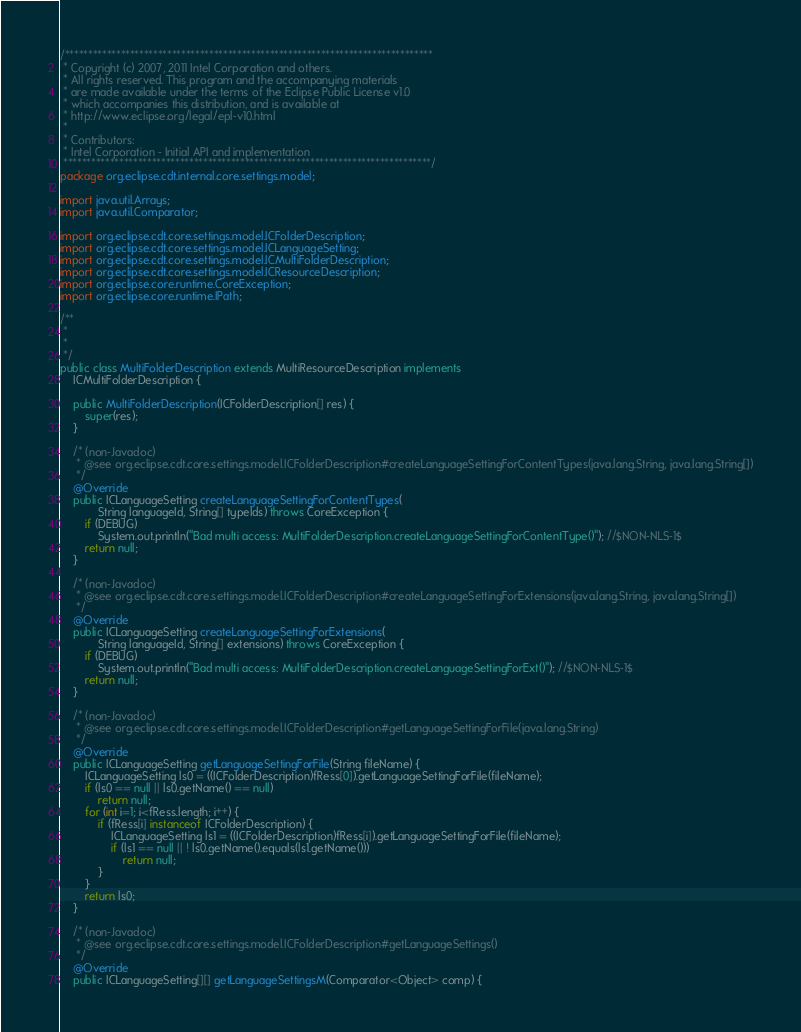<code> <loc_0><loc_0><loc_500><loc_500><_Java_>/*******************************************************************************
 * Copyright (c) 2007, 2011 Intel Corporation and others.
 * All rights reserved. This program and the accompanying materials
 * are made available under the terms of the Eclipse Public License v1.0
 * which accompanies this distribution, and is available at
 * http://www.eclipse.org/legal/epl-v10.html
 *
 * Contributors:
 * Intel Corporation - Initial API and implementation
 *******************************************************************************/
package org.eclipse.cdt.internal.core.settings.model;

import java.util.Arrays;
import java.util.Comparator;

import org.eclipse.cdt.core.settings.model.ICFolderDescription;
import org.eclipse.cdt.core.settings.model.ICLanguageSetting;
import org.eclipse.cdt.core.settings.model.ICMultiFolderDescription;
import org.eclipse.cdt.core.settings.model.ICResourceDescription;
import org.eclipse.core.runtime.CoreException;
import org.eclipse.core.runtime.IPath;

/**
 *
 *
 */
public class MultiFolderDescription extends MultiResourceDescription implements
	ICMultiFolderDescription {

	public MultiFolderDescription(ICFolderDescription[] res) {
		super(res);
	}

	/* (non-Javadoc)
	 * @see org.eclipse.cdt.core.settings.model.ICFolderDescription#createLanguageSettingForContentTypes(java.lang.String, java.lang.String[])
	 */
	@Override
	public ICLanguageSetting createLanguageSettingForContentTypes(
			String languageId, String[] typeIds) throws CoreException {
		if (DEBUG)
			System.out.println("Bad multi access: MultiFolderDescription.createLanguageSettingForContentType()"); //$NON-NLS-1$
		return null;
	}

	/* (non-Javadoc)
	 * @see org.eclipse.cdt.core.settings.model.ICFolderDescription#createLanguageSettingForExtensions(java.lang.String, java.lang.String[])
	 */
	@Override
	public ICLanguageSetting createLanguageSettingForExtensions(
			String languageId, String[] extensions) throws CoreException {
		if (DEBUG)
			System.out.println("Bad multi access: MultiFolderDescription.createLanguageSettingForExt()"); //$NON-NLS-1$
		return null;
	}

	/* (non-Javadoc)
	 * @see org.eclipse.cdt.core.settings.model.ICFolderDescription#getLanguageSettingForFile(java.lang.String)
	 */
	@Override
	public ICLanguageSetting getLanguageSettingForFile(String fileName) {
		ICLanguageSetting ls0 = ((ICFolderDescription)fRess[0]).getLanguageSettingForFile(fileName);
		if (ls0 == null || ls0.getName() == null)
			return null;
		for (int i=1; i<fRess.length; i++) {
			if (fRess[i] instanceof ICFolderDescription) {
				ICLanguageSetting ls1 = ((ICFolderDescription)fRess[i]).getLanguageSettingForFile(fileName);
				if (ls1 == null || ! ls0.getName().equals(ls1.getName()))
					return null;
			}
		}
		return ls0;
	}

	/* (non-Javadoc)
	 * @see org.eclipse.cdt.core.settings.model.ICFolderDescription#getLanguageSettings()
	 */
	@Override
	public ICLanguageSetting[][] getLanguageSettingsM(Comparator<Object> comp) {</code> 